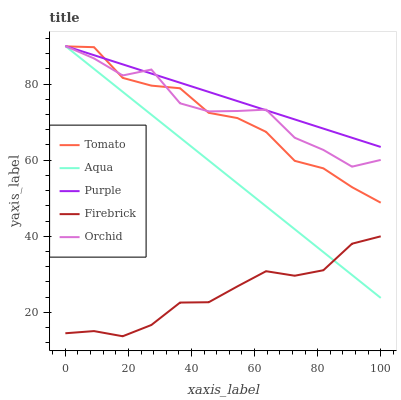Does Firebrick have the minimum area under the curve?
Answer yes or no. Yes. Does Purple have the maximum area under the curve?
Answer yes or no. Yes. Does Purple have the minimum area under the curve?
Answer yes or no. No. Does Firebrick have the maximum area under the curve?
Answer yes or no. No. Is Aqua the smoothest?
Answer yes or no. Yes. Is Orchid the roughest?
Answer yes or no. Yes. Is Purple the smoothest?
Answer yes or no. No. Is Purple the roughest?
Answer yes or no. No. Does Firebrick have the lowest value?
Answer yes or no. Yes. Does Purple have the lowest value?
Answer yes or no. No. Does Orchid have the highest value?
Answer yes or no. Yes. Does Firebrick have the highest value?
Answer yes or no. No. Is Firebrick less than Tomato?
Answer yes or no. Yes. Is Tomato greater than Firebrick?
Answer yes or no. Yes. Does Purple intersect Orchid?
Answer yes or no. Yes. Is Purple less than Orchid?
Answer yes or no. No. Is Purple greater than Orchid?
Answer yes or no. No. Does Firebrick intersect Tomato?
Answer yes or no. No. 